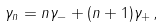Convert formula to latex. <formula><loc_0><loc_0><loc_500><loc_500>\gamma _ { n } = n \gamma _ { - } + ( n + 1 ) \gamma _ { + } \, ,</formula> 